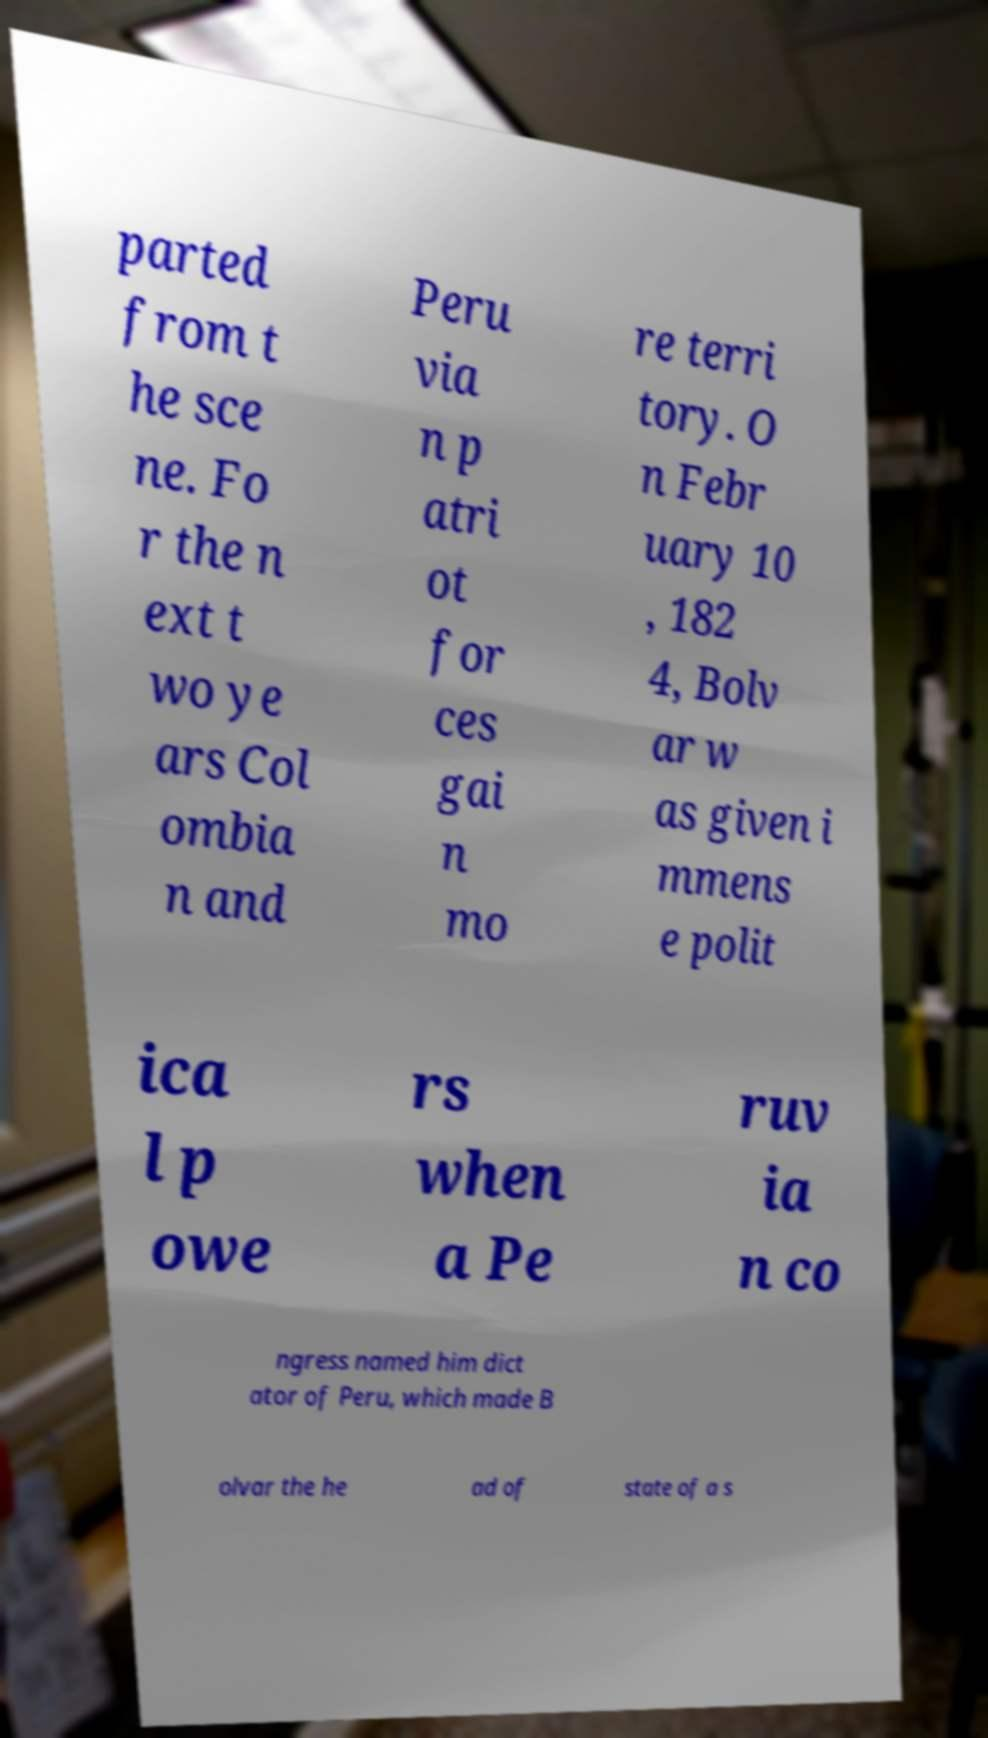There's text embedded in this image that I need extracted. Can you transcribe it verbatim? parted from t he sce ne. Fo r the n ext t wo ye ars Col ombia n and Peru via n p atri ot for ces gai n mo re terri tory. O n Febr uary 10 , 182 4, Bolv ar w as given i mmens e polit ica l p owe rs when a Pe ruv ia n co ngress named him dict ator of Peru, which made B olvar the he ad of state of a s 